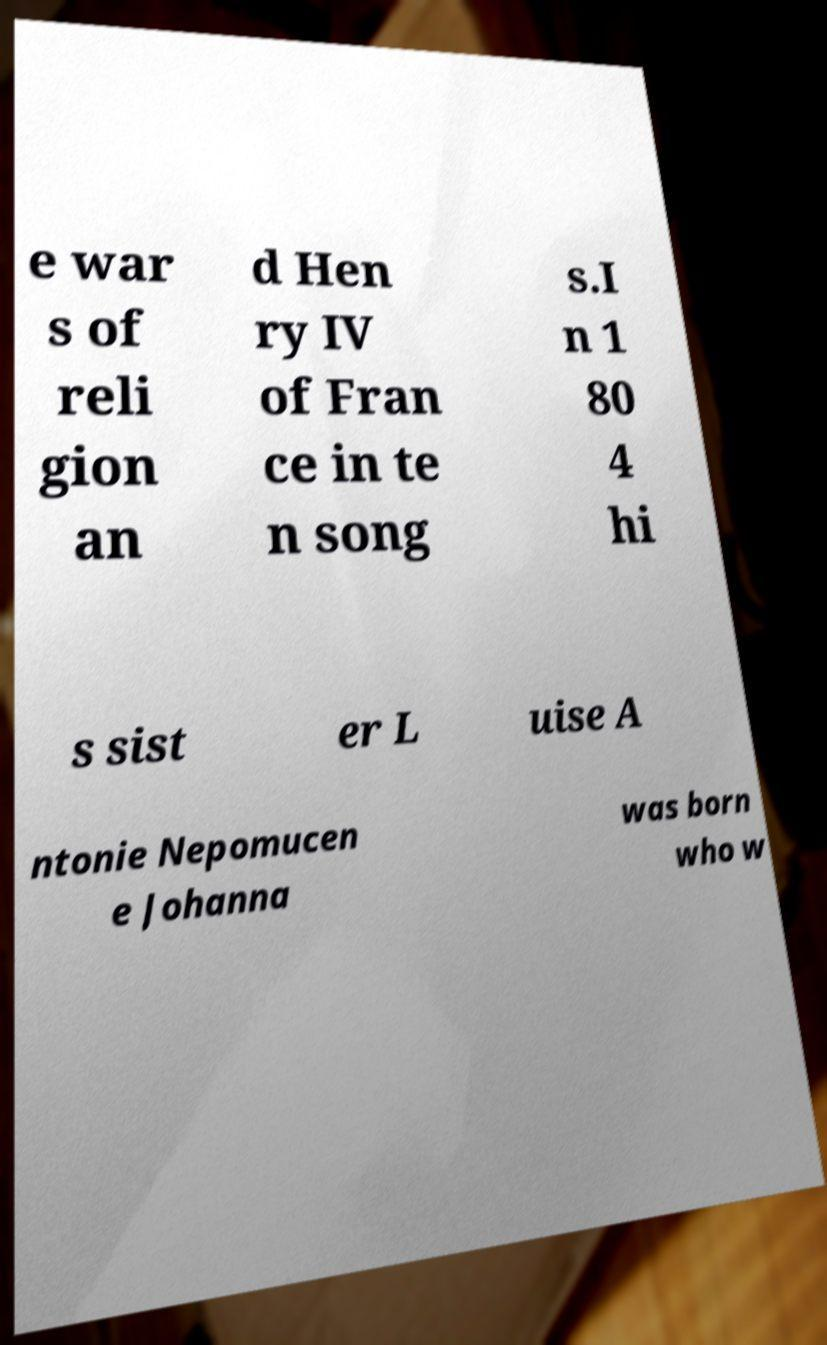Could you assist in decoding the text presented in this image and type it out clearly? e war s of reli gion an d Hen ry IV of Fran ce in te n song s.I n 1 80 4 hi s sist er L uise A ntonie Nepomucen e Johanna was born who w 